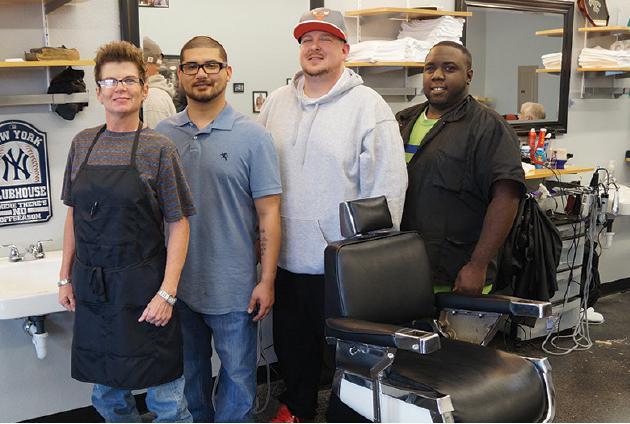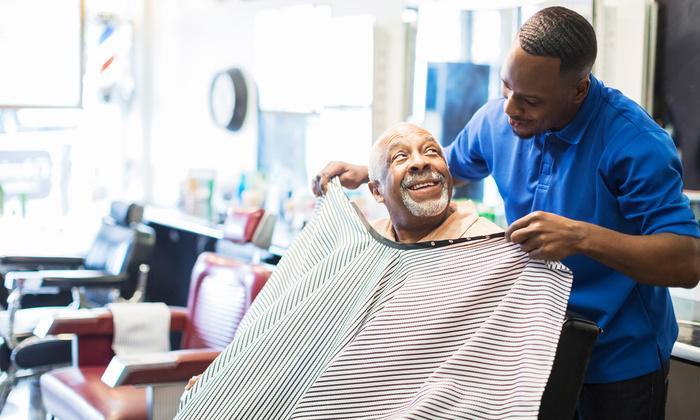The first image is the image on the left, the second image is the image on the right. For the images displayed, is the sentence "At least one person is wearing eyeglasses in one of the images." factually correct? Answer yes or no. Yes. The first image is the image on the left, the second image is the image on the right. Given the left and right images, does the statement "A forward-facing man who is not a customer sits on a barber chair in the center of one scene." hold true? Answer yes or no. No. 